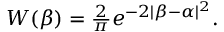<formula> <loc_0><loc_0><loc_500><loc_500>\begin{array} { r } { W ( \beta ) = \frac { 2 } { \pi } e ^ { - 2 | \beta - \alpha | ^ { 2 } } . } \end{array}</formula> 